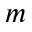<formula> <loc_0><loc_0><loc_500><loc_500>m</formula> 